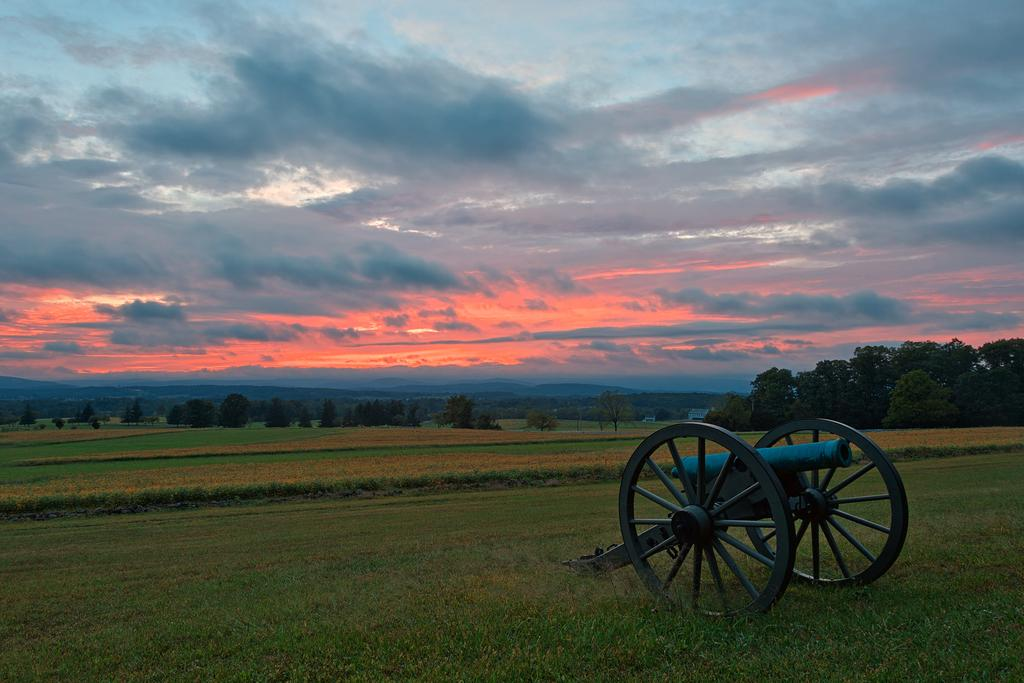What type of water feature is on the right side of the image? There is a canal on the right side of the image. What type of vegetation is at the bottom of the image? There is grass at the bottom of the image. What can be seen in the background of the image? There are trees and hills in the background of the image. What is visible in the sky in the image? The sky is visible in the background of the image. What type of apparatus is used to measure the texture of the grass in the image? There is no apparatus present in the image to measure the texture of the grass. What type of house is visible in the image? There is no house visible in the image. 